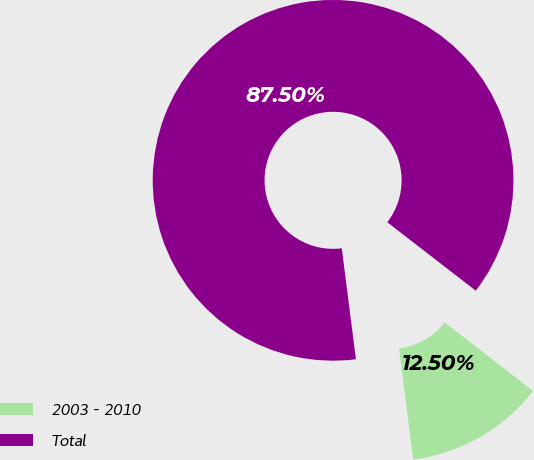Convert chart. <chart><loc_0><loc_0><loc_500><loc_500><pie_chart><fcel>2003 - 2010<fcel>Total<nl><fcel>12.5%<fcel>87.5%<nl></chart> 